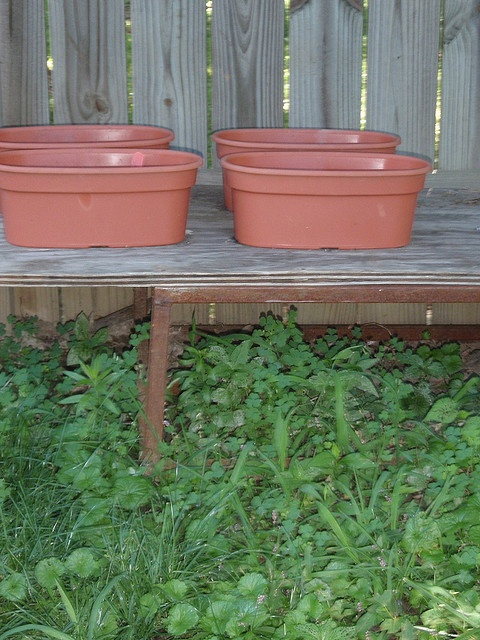Describe the objects in this image and their specific colors. I can see a bench in gray and darkgray tones in this image. 